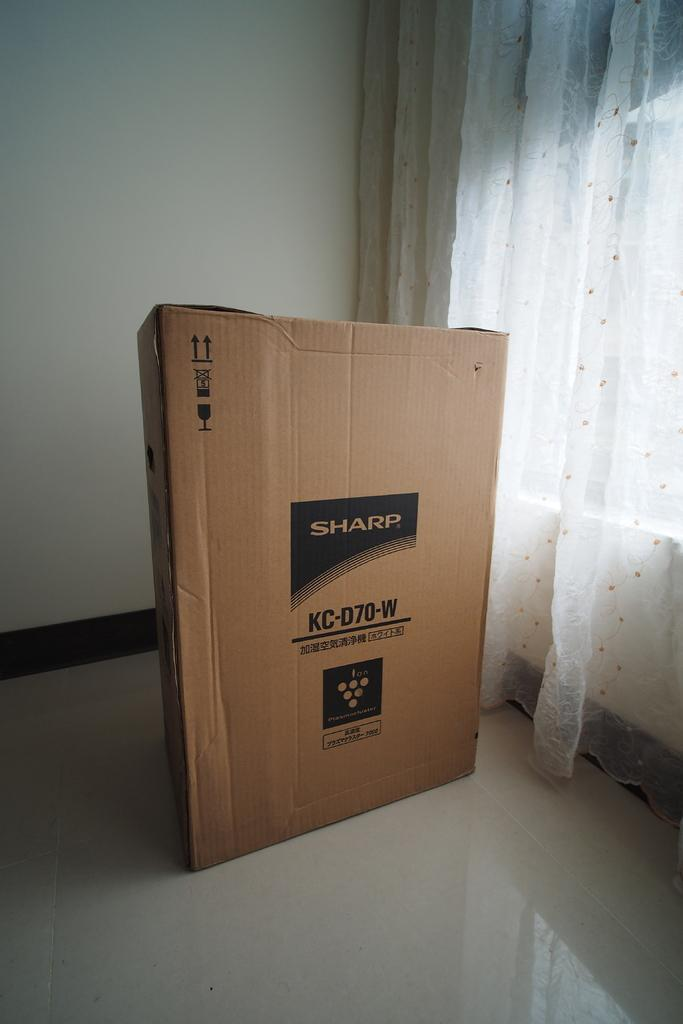Provide a one-sentence caption for the provided image. A Sharp TV box in an empty room with white curtains. 